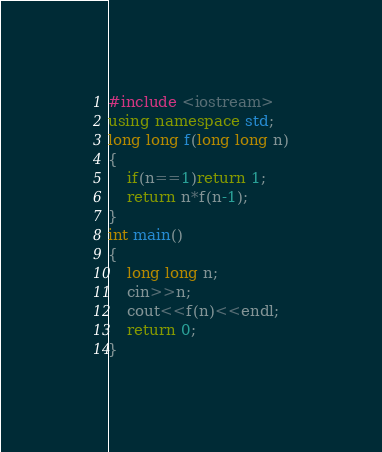<code> <loc_0><loc_0><loc_500><loc_500><_C++_>#include <iostream>
using namespace std;
long long f(long long n)
{
    if(n==1)return 1;
    return n*f(n-1);
}
int main()
{
    long long n;
    cin>>n;
    cout<<f(n)<<endl;
    return 0;
}</code> 